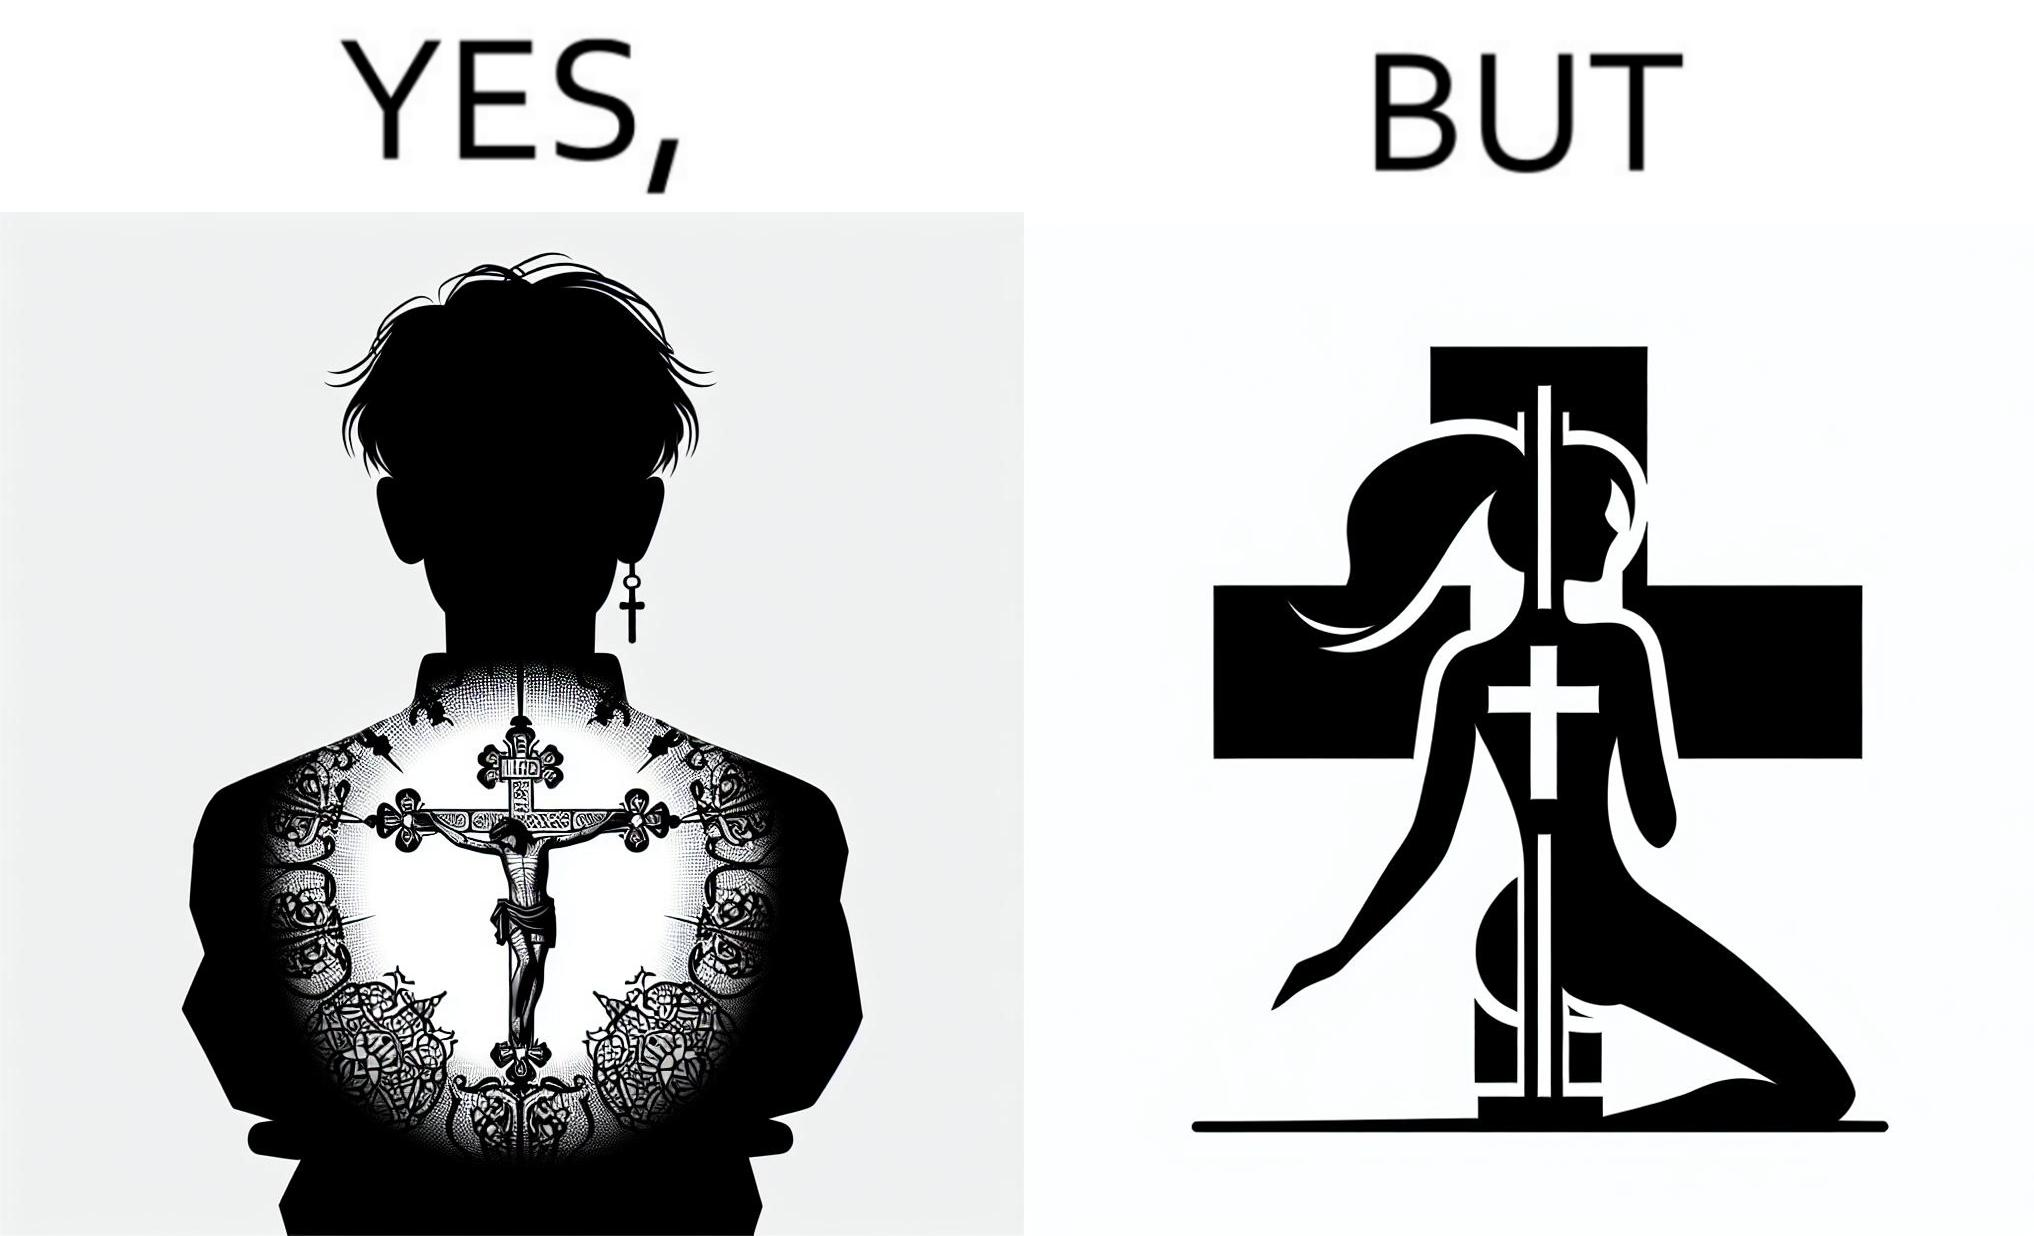Explain the humor or irony in this image. This image may present two different ideas, firstly even she is such a believer in god that she has got a tatto of holy cross symbol on her back but her situations have forced her to do a job at a bar or some place performing pole dance and secondly she is using a religious symbol to glorify her look so that more people acknowledge her dance and give her some money 